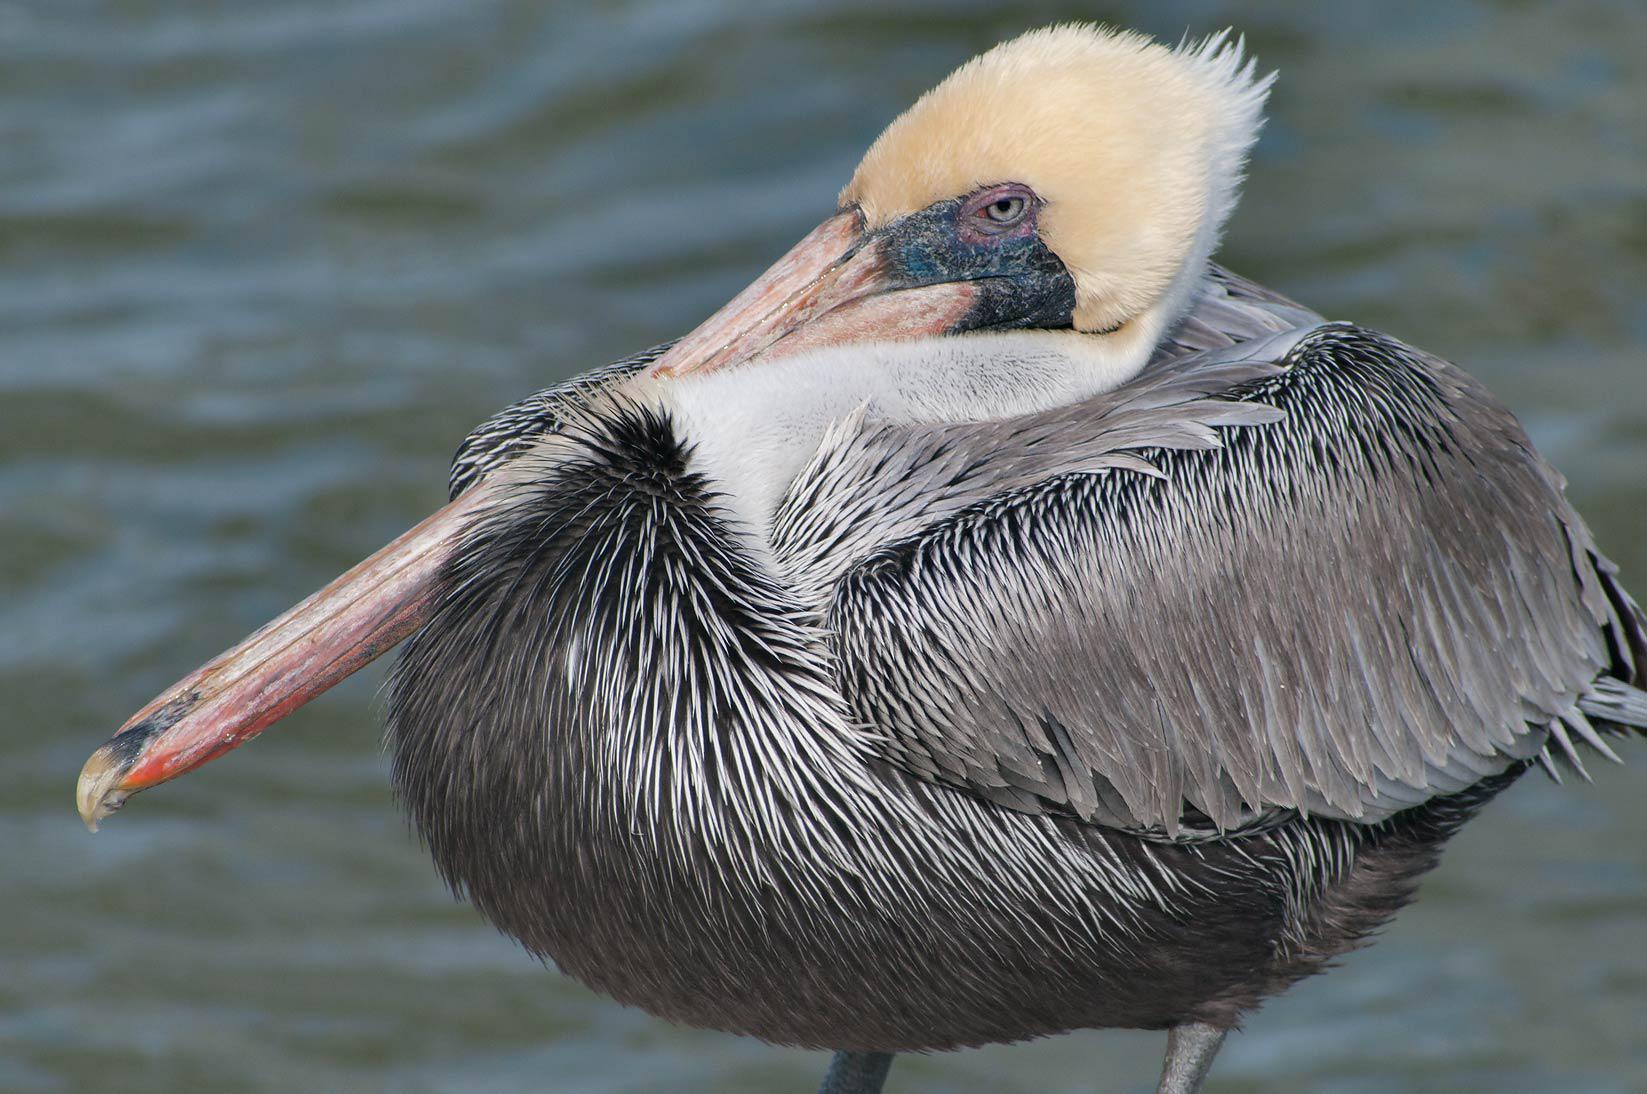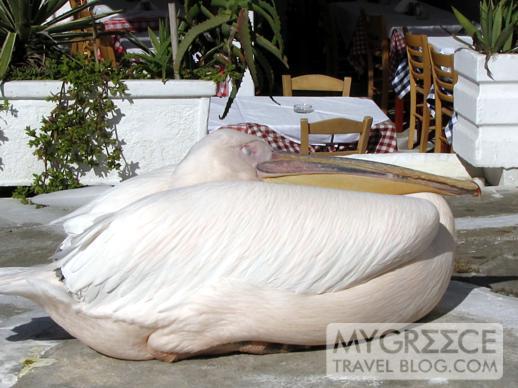The first image is the image on the left, the second image is the image on the right. Evaluate the accuracy of this statement regarding the images: "There is a bird facing towards the left in the left image.". Is it true? Answer yes or no. Yes. The first image is the image on the left, the second image is the image on the right. Evaluate the accuracy of this statement regarding the images: "Each image contains exactly one pelican, and all pelicans have a flattened pose with bill resting on breast.". Is it true? Answer yes or no. Yes. 